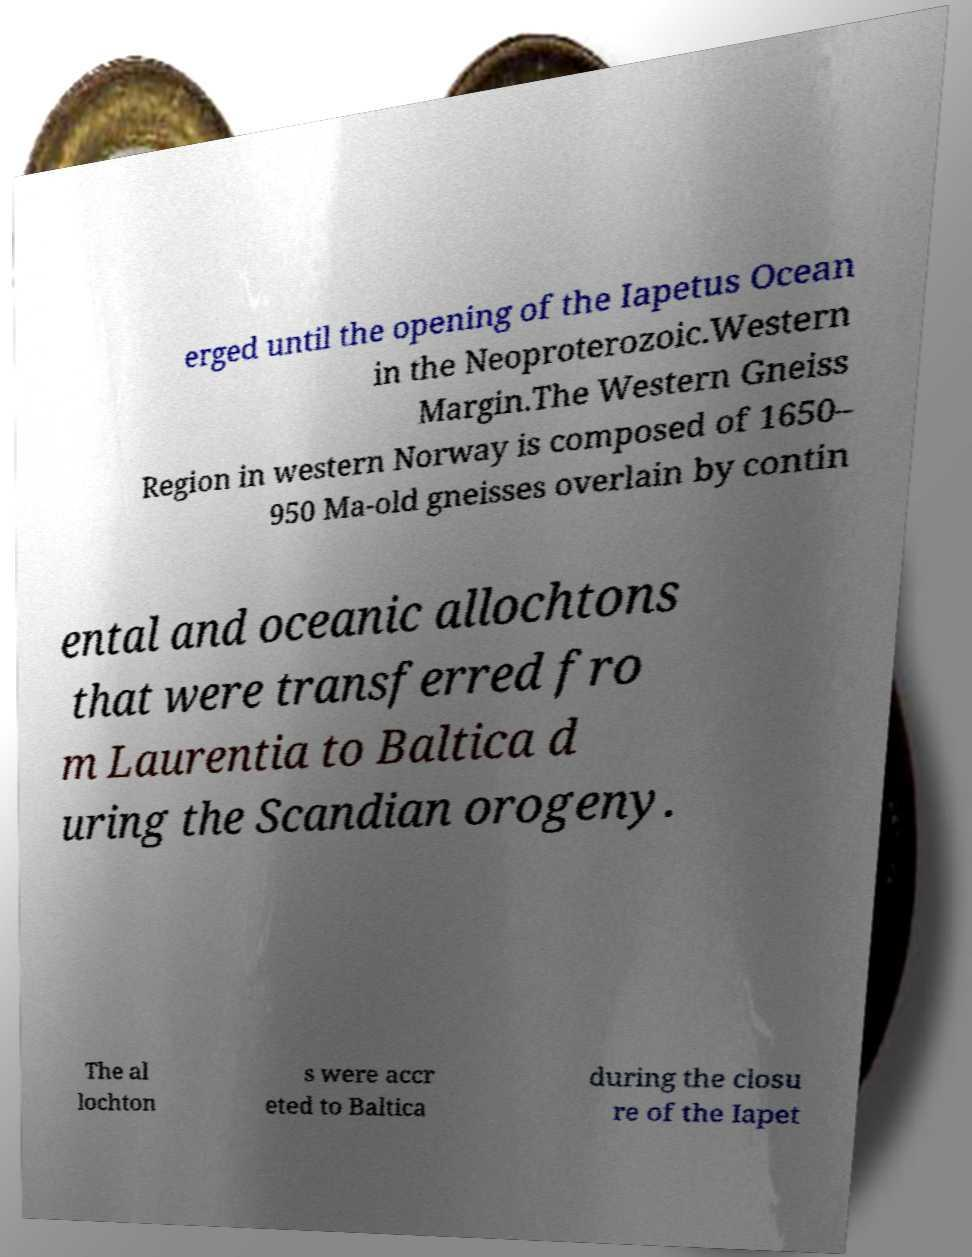Please identify and transcribe the text found in this image. erged until the opening of the Iapetus Ocean in the Neoproterozoic.Western Margin.The Western Gneiss Region in western Norway is composed of 1650– 950 Ma-old gneisses overlain by contin ental and oceanic allochtons that were transferred fro m Laurentia to Baltica d uring the Scandian orogeny. The al lochton s were accr eted to Baltica during the closu re of the Iapet 